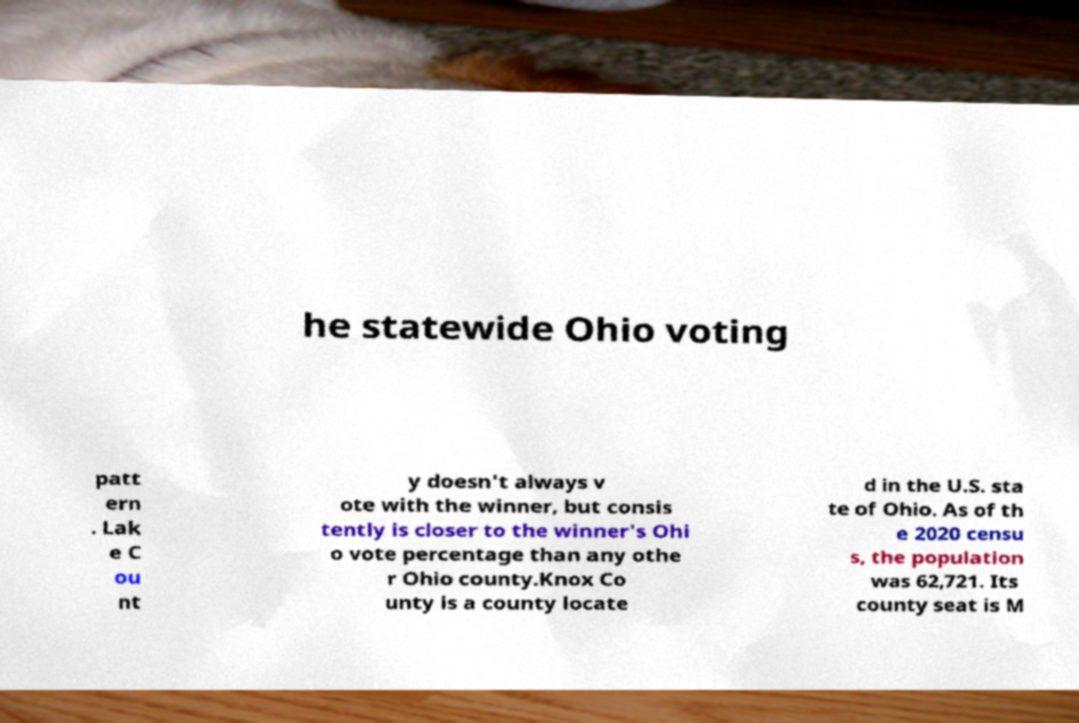Can you accurately transcribe the text from the provided image for me? he statewide Ohio voting patt ern . Lak e C ou nt y doesn't always v ote with the winner, but consis tently is closer to the winner's Ohi o vote percentage than any othe r Ohio county.Knox Co unty is a county locate d in the U.S. sta te of Ohio. As of th e 2020 censu s, the population was 62,721. Its county seat is M 